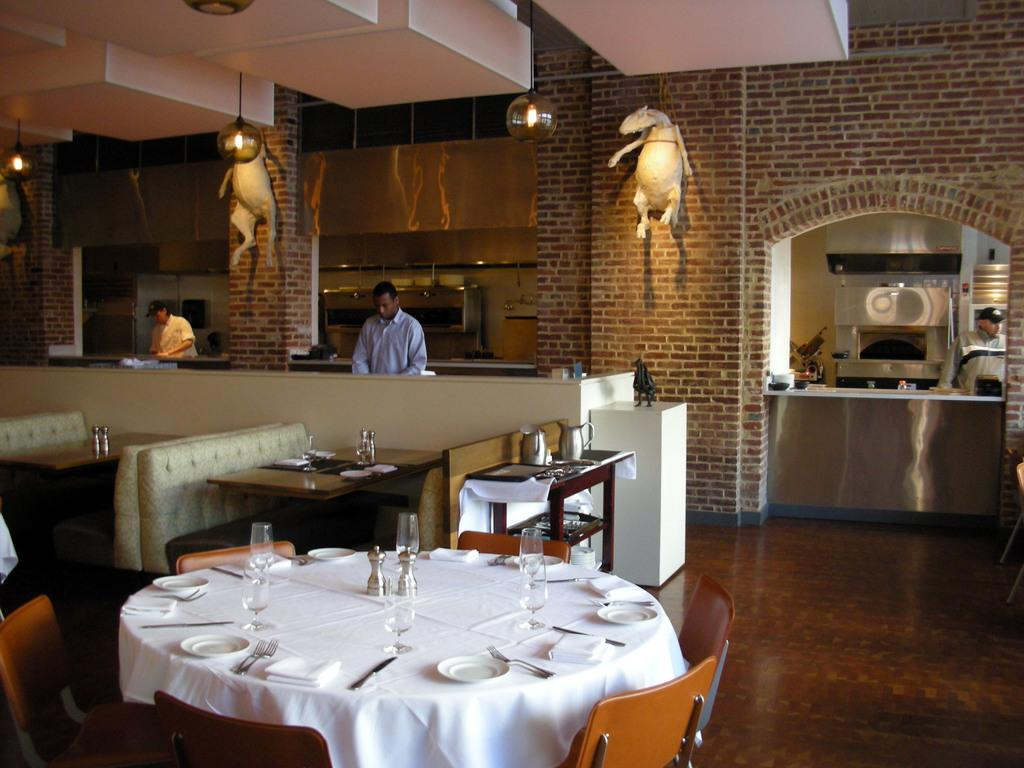What type of furniture is present in the image? There are tables and chairs in the image. What is placed on the tables? There are objects on the tables. What can be seen in the background of the image? There is a wall and lights in the background of the image. How many men are visible in the background of the image? There are 3 men in the background of the image. What type of equipment can be seen in the image? There are equipment visible in the image. What type of underwear is the man in the background wearing in the image? There is no information about the men's clothing in the image, so it cannot be determined what type of underwear they are wearing. What message of peace can be seen in the image? There is no message of peace or any text present in the image. Are there any yaks visible in the image? There are no yaks present in the image. 